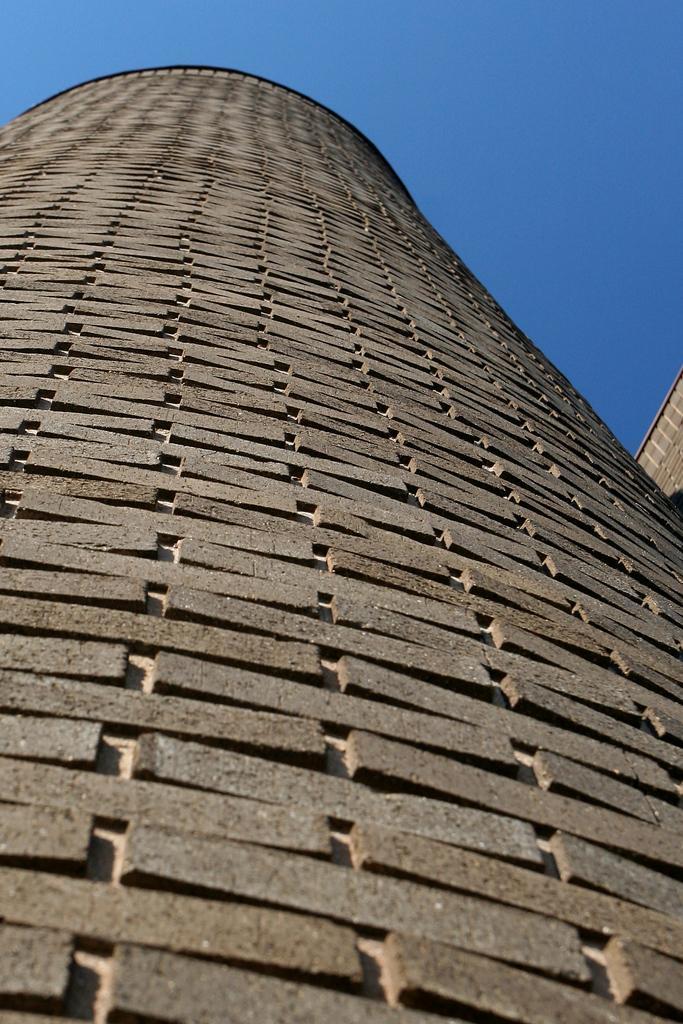Describe this image in one or two sentences. In the center of the image, we can see buildings and in the background, there is sky. 